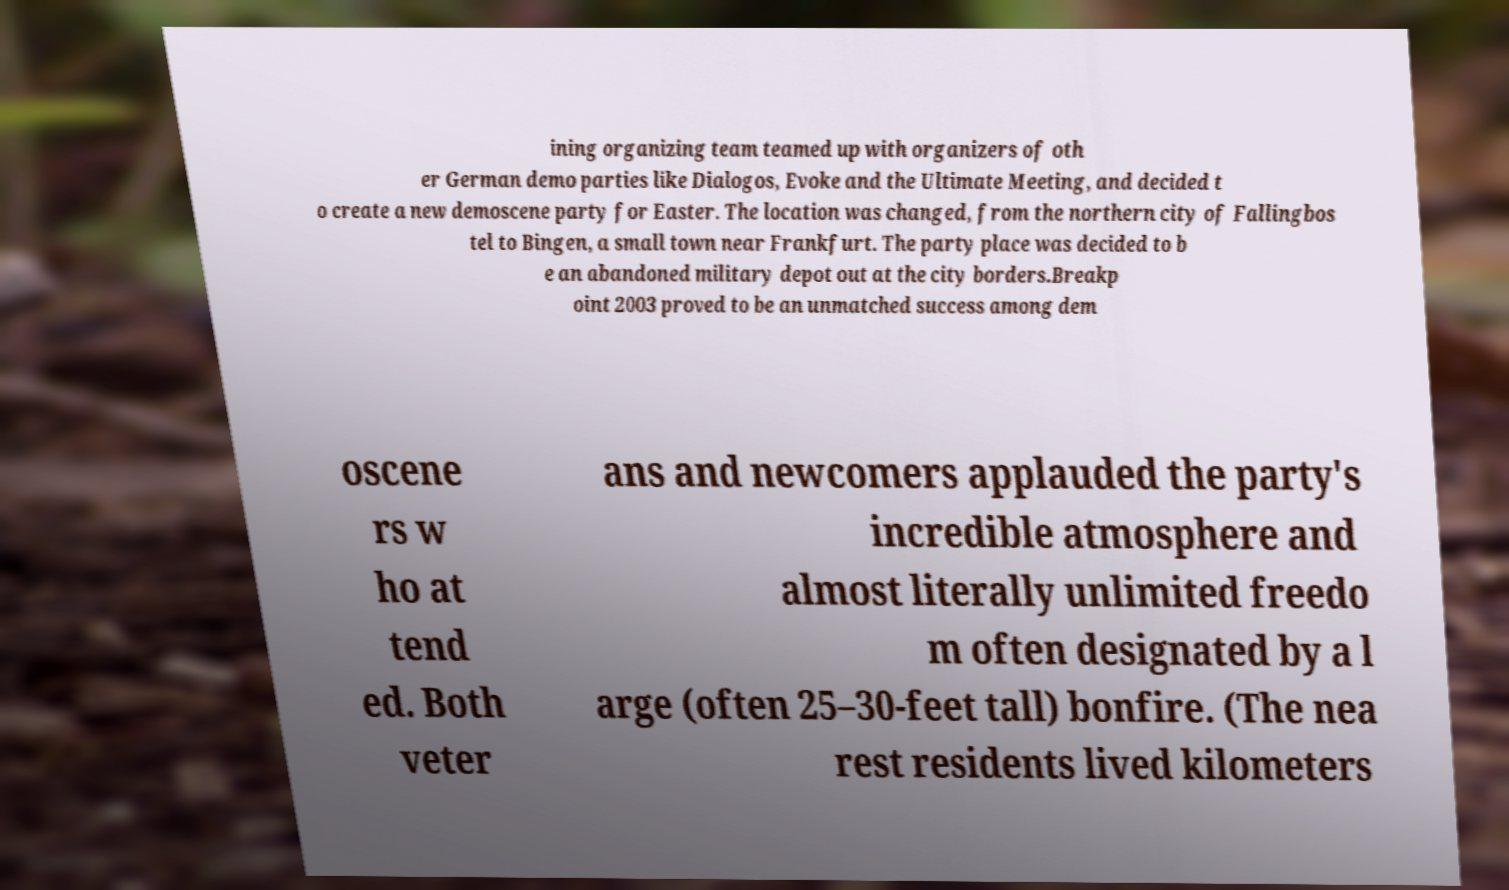There's text embedded in this image that I need extracted. Can you transcribe it verbatim? ining organizing team teamed up with organizers of oth er German demo parties like Dialogos, Evoke and the Ultimate Meeting, and decided t o create a new demoscene party for Easter. The location was changed, from the northern city of Fallingbos tel to Bingen, a small town near Frankfurt. The party place was decided to b e an abandoned military depot out at the city borders.Breakp oint 2003 proved to be an unmatched success among dem oscene rs w ho at tend ed. Both veter ans and newcomers applauded the party's incredible atmosphere and almost literally unlimited freedo m often designated by a l arge (often 25–30-feet tall) bonfire. (The nea rest residents lived kilometers 